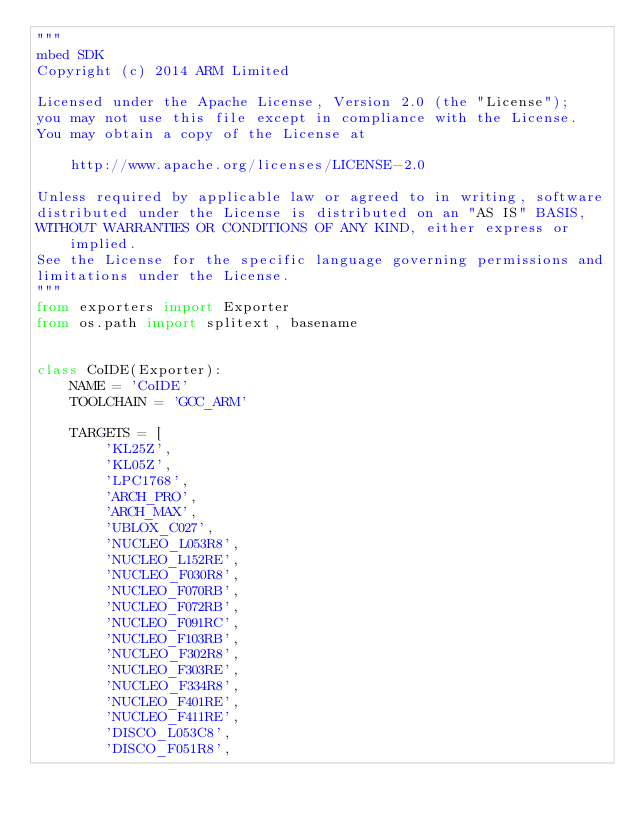<code> <loc_0><loc_0><loc_500><loc_500><_Python_>"""
mbed SDK
Copyright (c) 2014 ARM Limited

Licensed under the Apache License, Version 2.0 (the "License");
you may not use this file except in compliance with the License.
You may obtain a copy of the License at

    http://www.apache.org/licenses/LICENSE-2.0

Unless required by applicable law or agreed to in writing, software
distributed under the License is distributed on an "AS IS" BASIS,
WITHOUT WARRANTIES OR CONDITIONS OF ANY KIND, either express or implied.
See the License for the specific language governing permissions and
limitations under the License.
"""
from exporters import Exporter
from os.path import splitext, basename


class CoIDE(Exporter):
    NAME = 'CoIDE'
    TOOLCHAIN = 'GCC_ARM'

    TARGETS = [
        'KL25Z',
        'KL05Z',
        'LPC1768',
        'ARCH_PRO',
        'ARCH_MAX',
        'UBLOX_C027',
        'NUCLEO_L053R8',
        'NUCLEO_L152RE',
        'NUCLEO_F030R8',
        'NUCLEO_F070RB',
        'NUCLEO_F072RB',
        'NUCLEO_F091RC',
        'NUCLEO_F103RB',
        'NUCLEO_F302R8',
        'NUCLEO_F303RE',
        'NUCLEO_F334R8',
        'NUCLEO_F401RE',
        'NUCLEO_F411RE',
        'DISCO_L053C8',
        'DISCO_F051R8',</code> 